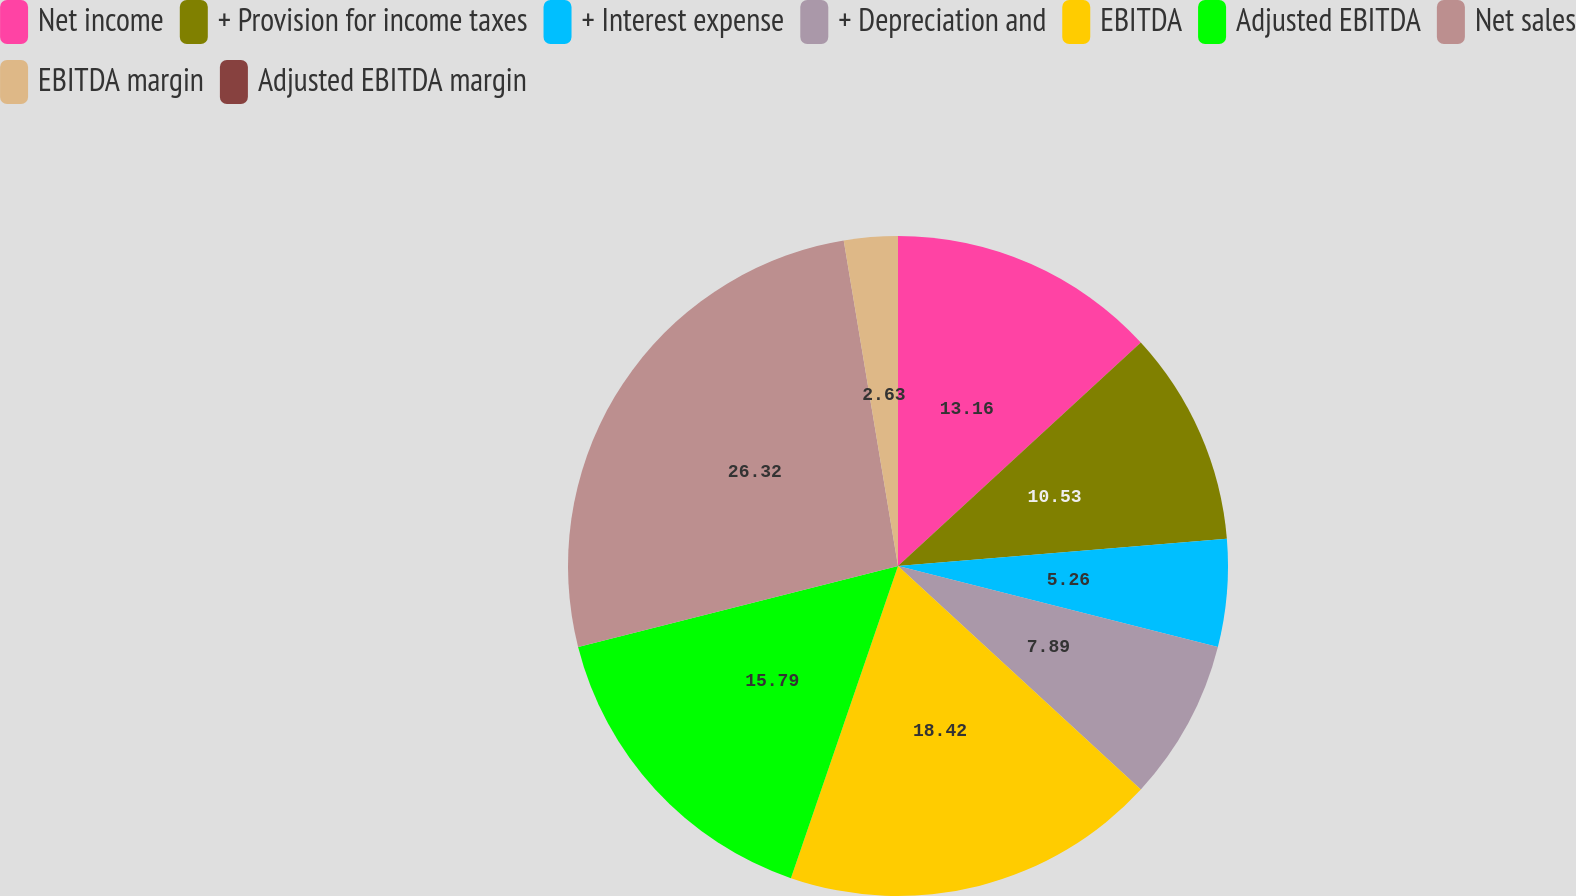Convert chart to OTSL. <chart><loc_0><loc_0><loc_500><loc_500><pie_chart><fcel>Net income<fcel>+ Provision for income taxes<fcel>+ Interest expense<fcel>+ Depreciation and<fcel>EBITDA<fcel>Adjusted EBITDA<fcel>Net sales<fcel>EBITDA margin<fcel>Adjusted EBITDA margin<nl><fcel>13.16%<fcel>10.53%<fcel>5.26%<fcel>7.89%<fcel>18.42%<fcel>15.79%<fcel>26.32%<fcel>2.63%<fcel>0.0%<nl></chart> 